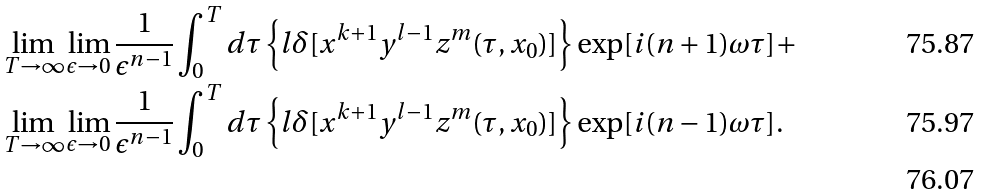Convert formula to latex. <formula><loc_0><loc_0><loc_500><loc_500>& \lim _ { T \rightarrow \infty } \lim _ { \epsilon \rightarrow 0 } \frac { 1 } { \epsilon ^ { n - 1 } } \int _ { 0 } ^ { T } d \tau \left \{ l \delta [ x ^ { k + 1 } y ^ { l - 1 } z ^ { m } ( \tau , x _ { 0 } ) ] \right \} \exp [ i ( n + 1 ) \omega \tau ] + \\ & \lim _ { T \rightarrow \infty } \lim _ { \epsilon \rightarrow 0 } \frac { 1 } { \epsilon ^ { n - 1 } } \int _ { 0 } ^ { T } d \tau \left \{ l \delta [ x ^ { k + 1 } y ^ { l - 1 } z ^ { m } ( \tau , x _ { 0 } ) ] \right \} \exp [ i ( n - 1 ) \omega \tau ] . \\</formula> 